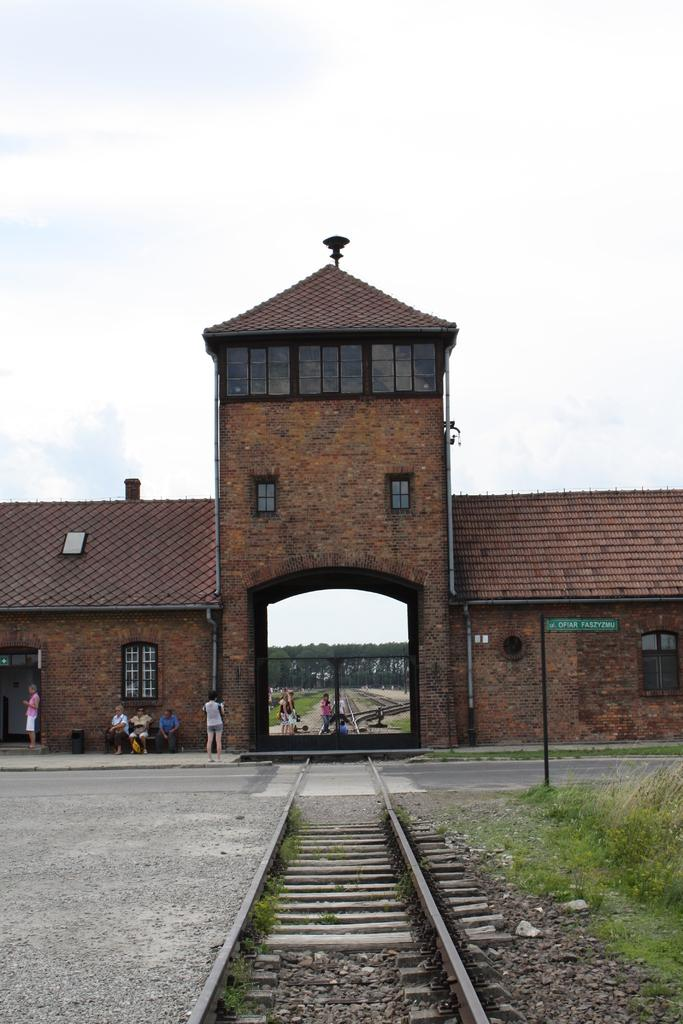What type of structure is visible in the image? There is a building with a roof and windows in the image. What can be seen on the ground in the image? There is a track and grass in the image. What is attached to a pole in the image? There is a board attached to a pole in the image. Can you describe the people in the image? There are people sitting in the image. Where is the river flowing in the image? There is no river present in the image. What type of berry is being picked by the people in the image? There are no berries or people picking berries in the image. 